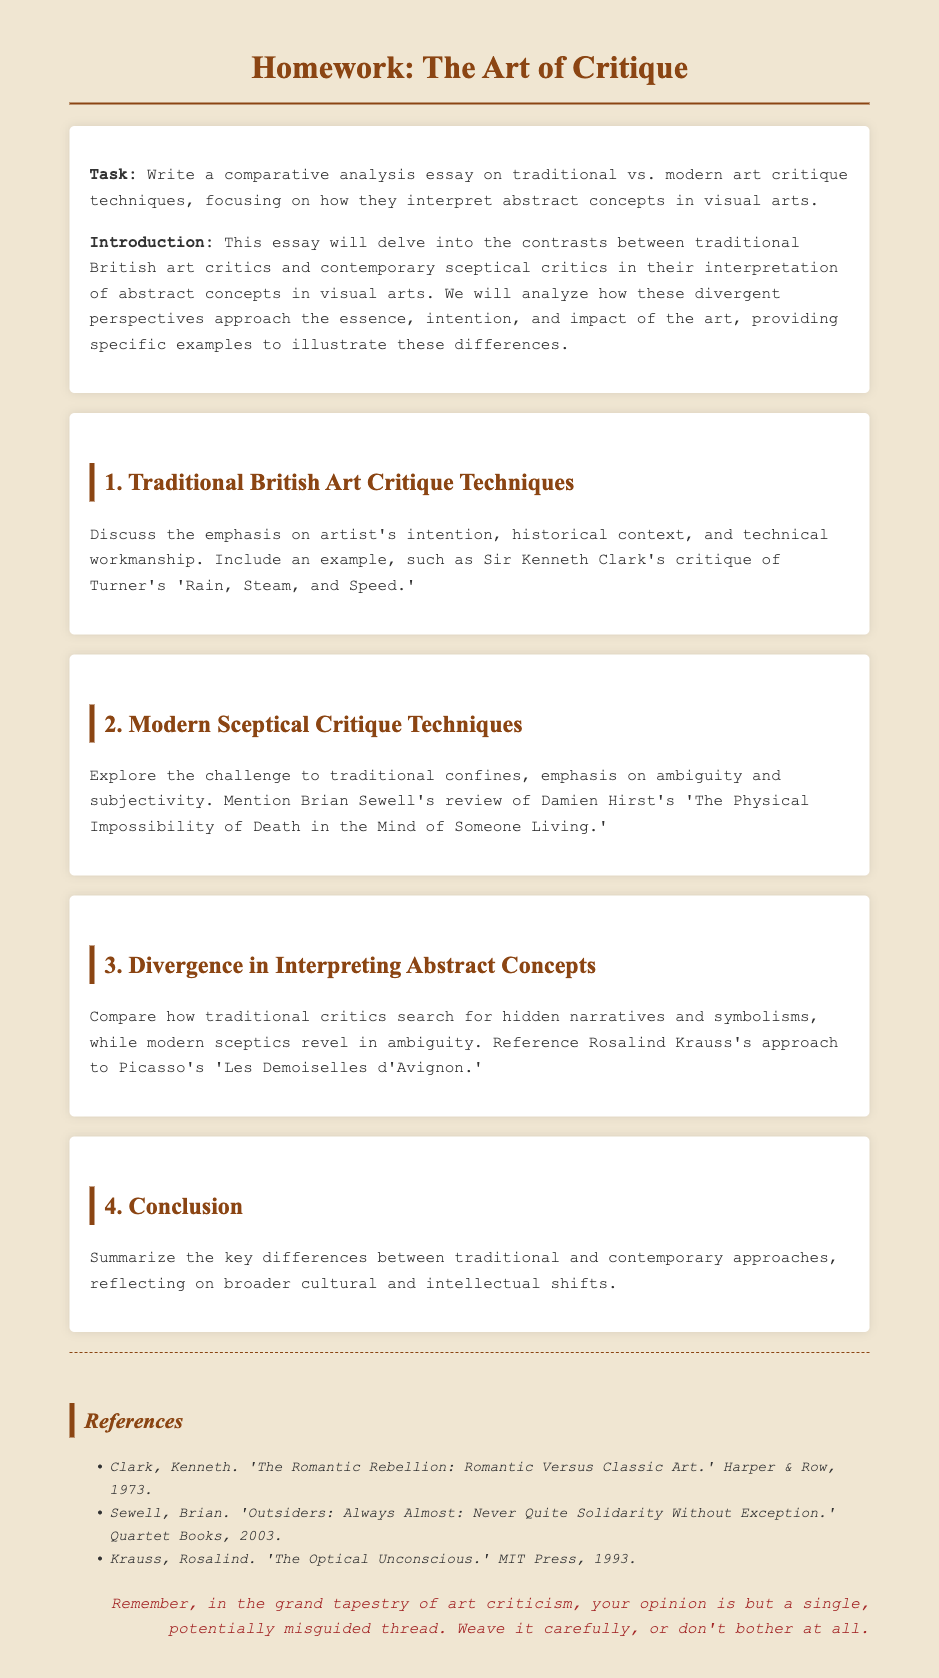What is the title of the homework? The title of the homework is found at the top of the document, outlining the assignment clearly.
Answer: The Art of Critique Who is the author of the critique on Turner's 'Rain, Steam, and Speed'? The document specifies that Sir Kenneth Clark is the critic discussed in relation to this artwork.
Answer: Sir Kenneth Clark What artwork does Brian Sewell critique? The document mentions Brian Sewell's review specifically titles a well-known piece by Damien Hirst.
Answer: The Physical Impossibility of Death in the Mind of Someone Living What approach does Rosalind Krauss take in her critique? The document describes her approach to Picasso's work highlighting a specific interpretation method.
Answer: Ambiguity What is the main focus of traditional British art critique techniques? According to the text, traditional critics focus on specific aspects related to the artist and their context.
Answer: Artist's intention What did the modern sceptical critics emphasize according to the document? The modern critics are noted for their approach towards specific thematic elements that define their critique style.
Answer: Ambiguity and subjectivity How does the document classify its sections? The structure of the document is organized in a systematic way, with clear headings for each part.
Answer: Sections What kind of note is included at the end of the document? The closing remark in the document adds a layer of sarcasm to the overall critique process.
Answer: Sarcastic note How many references are listed in the document? The number of cited works in the references section provides a clear insight into the sources used.
Answer: Three 